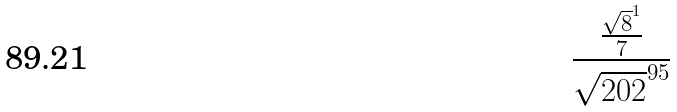Convert formula to latex. <formula><loc_0><loc_0><loc_500><loc_500>\frac { \frac { \sqrt { 8 } ^ { 1 } } { 7 } } { \sqrt { 2 0 2 } ^ { 9 5 } }</formula> 